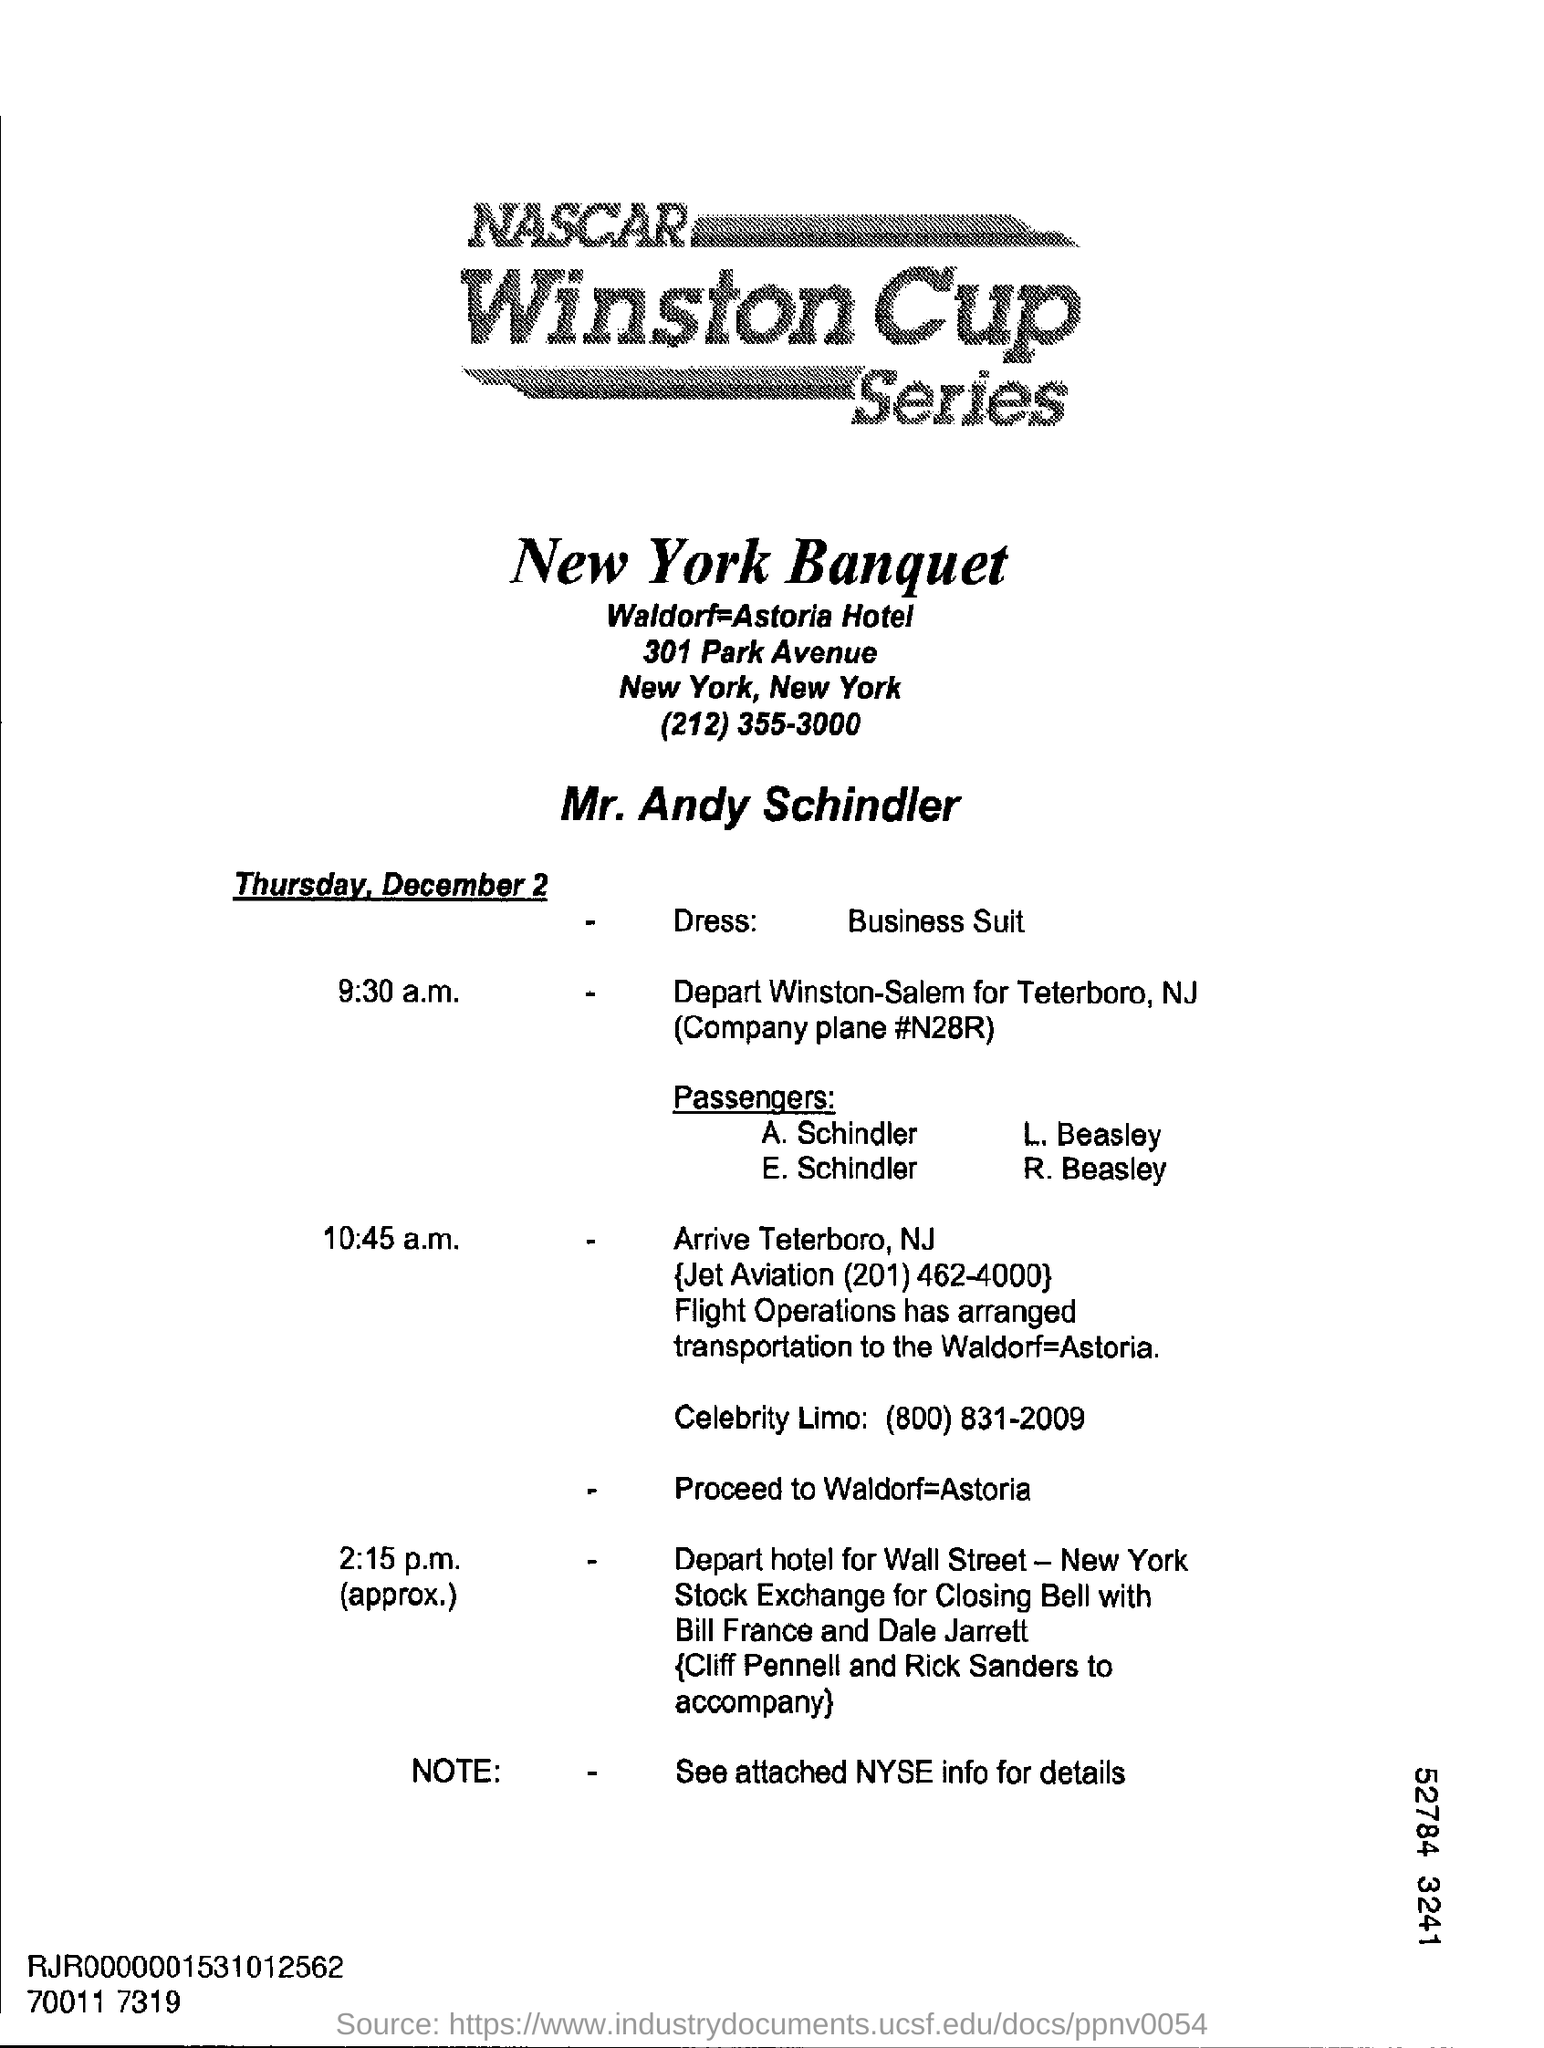List a handful of essential elements in this visual. What is the dress mentioned? It is a business suit. The date mentioned is Thursday, December 2. 